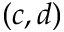<formula> <loc_0><loc_0><loc_500><loc_500>( c , d )</formula> 